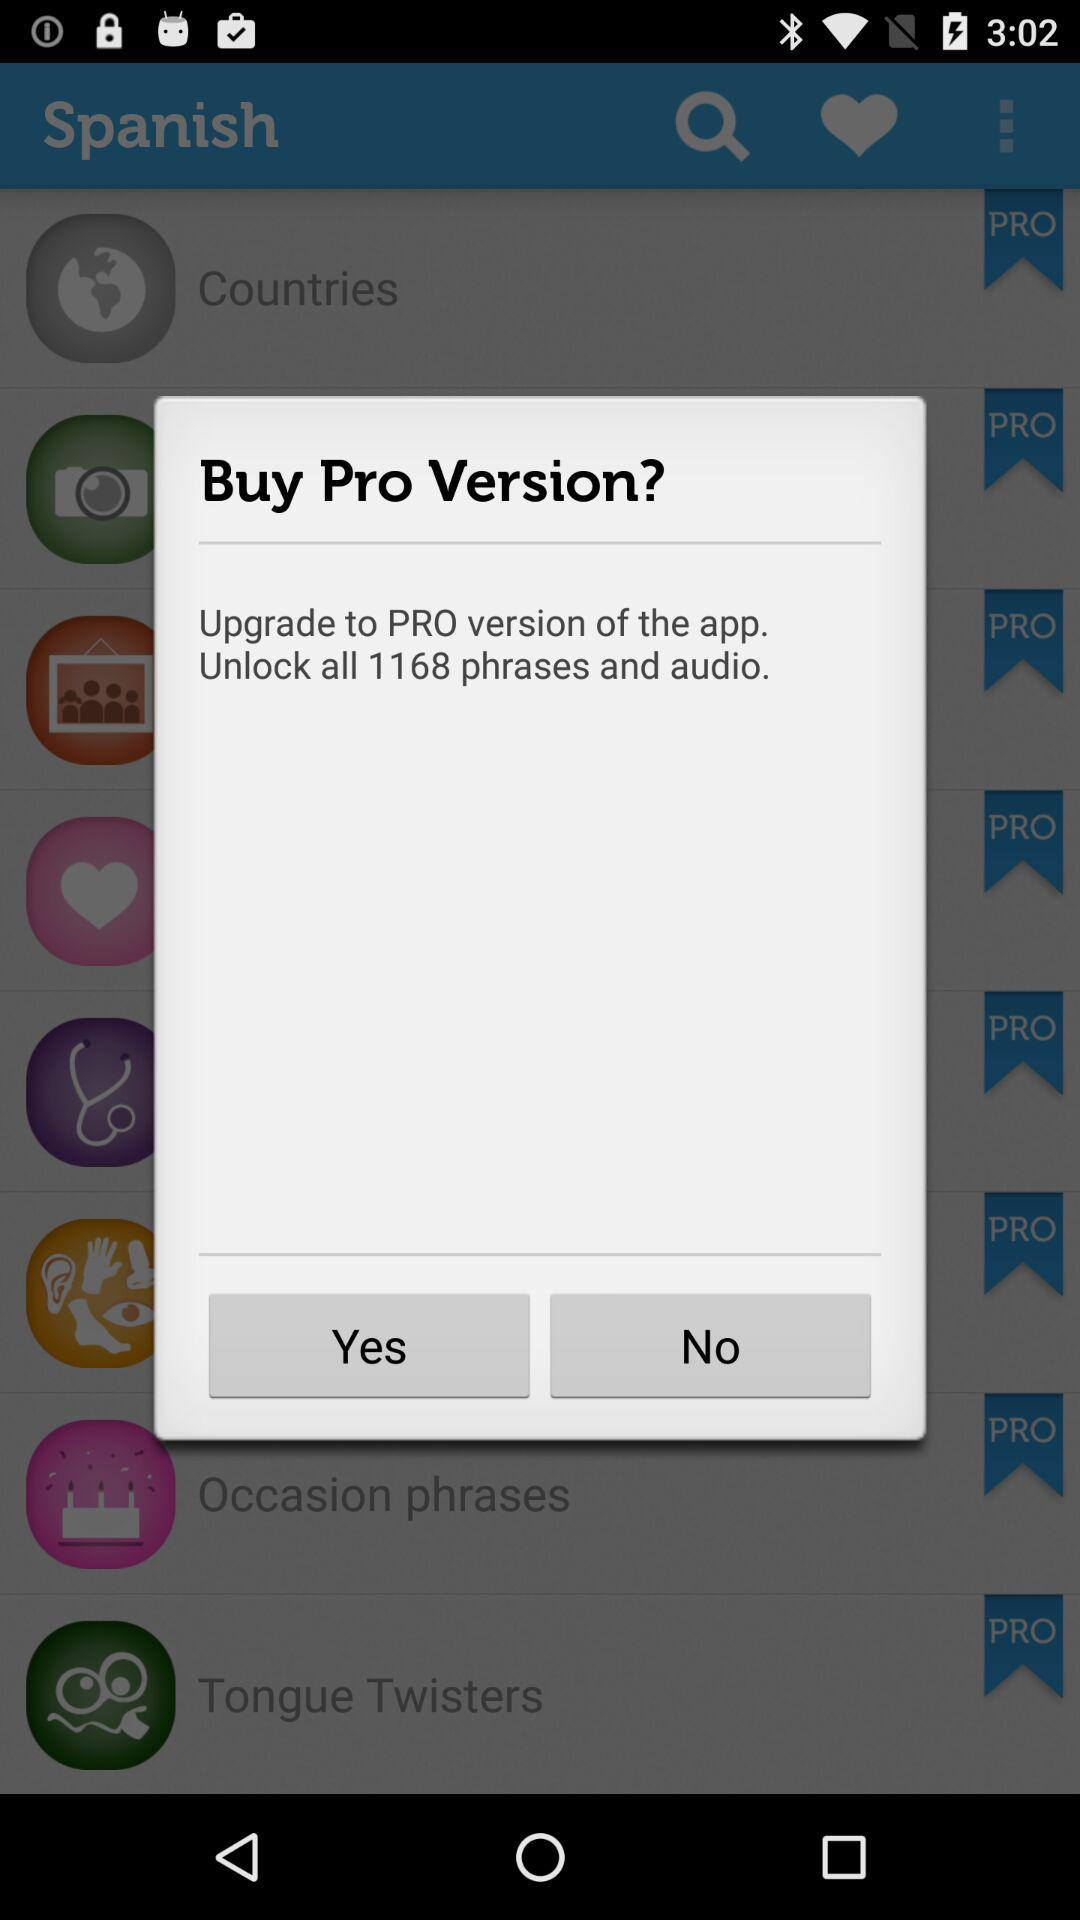Which version is the application asking to upgrade to? The application is asking to upgrade to the PRO version. 